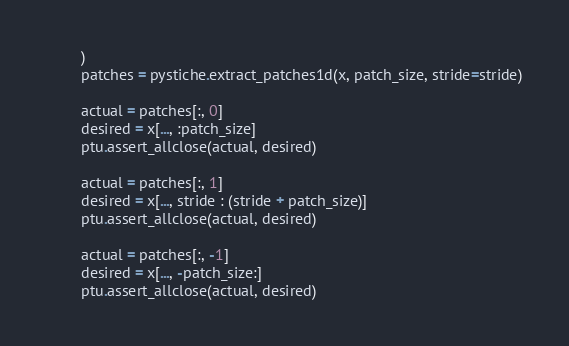Convert code to text. <code><loc_0><loc_0><loc_500><loc_500><_Python_>        )
        patches = pystiche.extract_patches1d(x, patch_size, stride=stride)

        actual = patches[:, 0]
        desired = x[..., :patch_size]
        ptu.assert_allclose(actual, desired)

        actual = patches[:, 1]
        desired = x[..., stride : (stride + patch_size)]
        ptu.assert_allclose(actual, desired)

        actual = patches[:, -1]
        desired = x[..., -patch_size:]
        ptu.assert_allclose(actual, desired)
</code> 